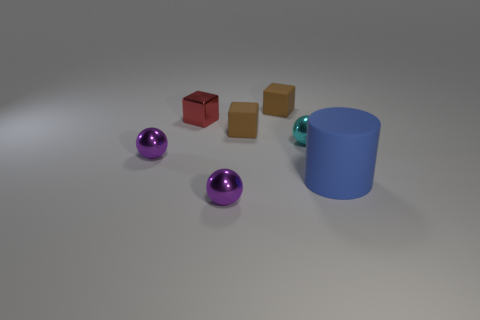What number of shiny things are either cyan things or tiny brown cubes?
Ensure brevity in your answer.  1. Is there a cylinder?
Give a very brief answer. Yes. Is the small red shiny thing the same shape as the big blue rubber object?
Your response must be concise. No. There is a purple metallic thing on the right side of the purple metallic ball behind the large blue object; what number of brown rubber things are behind it?
Provide a succinct answer. 2. There is a tiny thing that is both in front of the red metallic object and behind the small cyan sphere; what material is it made of?
Ensure brevity in your answer.  Rubber. What color is the matte object that is in front of the small red object and on the left side of the blue object?
Your answer should be very brief. Brown. Is there anything else of the same color as the large rubber cylinder?
Provide a short and direct response. No. What is the shape of the purple shiny thing on the left side of the small block on the left side of the purple metal ball to the right of the red block?
Your answer should be very brief. Sphere. There is a shiny ball that is in front of the purple metal thing that is behind the big blue matte thing; what color is it?
Keep it short and to the point. Purple. How many other red things have the same material as the big object?
Your answer should be very brief. 0. 